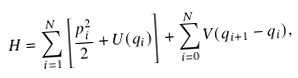<formula> <loc_0><loc_0><loc_500><loc_500>H = \sum _ { i = 1 } ^ { N } \left [ \frac { p _ { i } ^ { 2 } } { 2 } + U ( q _ { i } ) \right ] + \sum _ { i = 0 } ^ { N } V ( q _ { i + 1 } - q _ { i } ) ,</formula> 